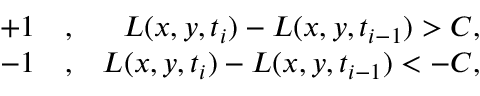<formula> <loc_0><loc_0><loc_500><loc_500>\begin{array} { r l r } { + 1 } & , } & { L ( x , y , t _ { i } ) - L ( x , y , t _ { i - 1 } ) > C , } \\ { - 1 } & , } & { L ( x , y , t _ { i } ) - L ( x , y , t _ { i - 1 } ) < - C , } \end{array}</formula> 